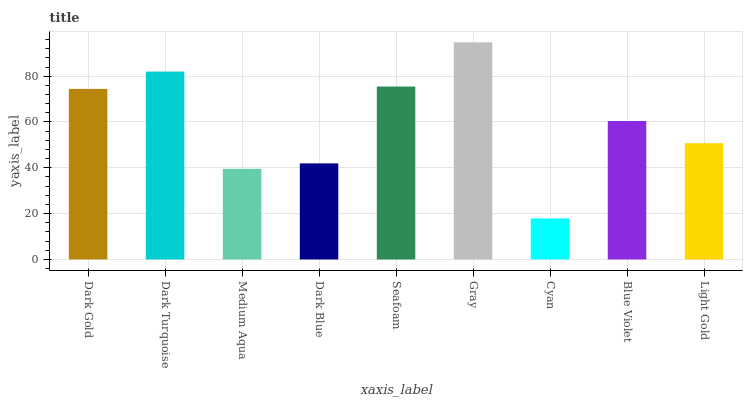Is Cyan the minimum?
Answer yes or no. Yes. Is Gray the maximum?
Answer yes or no. Yes. Is Dark Turquoise the minimum?
Answer yes or no. No. Is Dark Turquoise the maximum?
Answer yes or no. No. Is Dark Turquoise greater than Dark Gold?
Answer yes or no. Yes. Is Dark Gold less than Dark Turquoise?
Answer yes or no. Yes. Is Dark Gold greater than Dark Turquoise?
Answer yes or no. No. Is Dark Turquoise less than Dark Gold?
Answer yes or no. No. Is Blue Violet the high median?
Answer yes or no. Yes. Is Blue Violet the low median?
Answer yes or no. Yes. Is Light Gold the high median?
Answer yes or no. No. Is Cyan the low median?
Answer yes or no. No. 